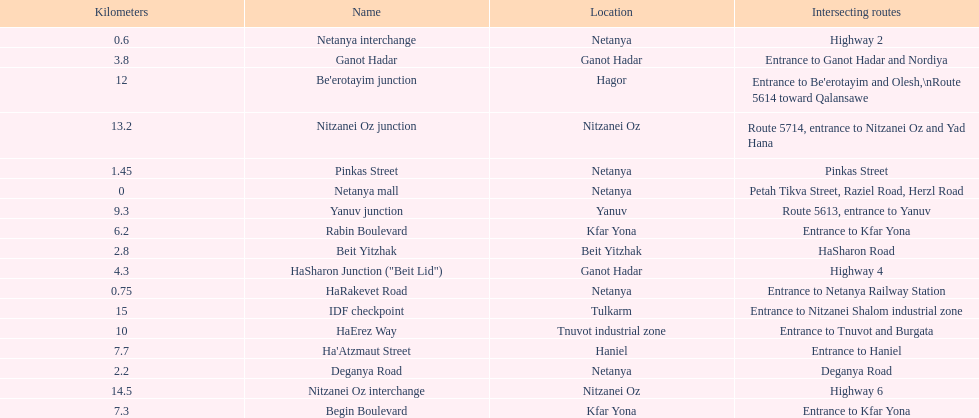Which portion has the same intersecting route as rabin boulevard? Begin Boulevard. 